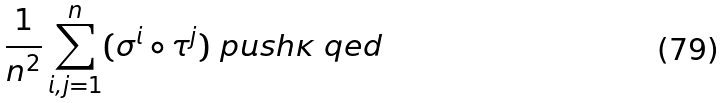<formula> <loc_0><loc_0><loc_500><loc_500>\frac { 1 } { n ^ { 2 } } \sum _ { i , j = 1 } ^ { n } ( \sigma ^ { i } \circ \tau ^ { j } ) \ p u s h \kappa \ q e d</formula> 